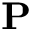<formula> <loc_0><loc_0><loc_500><loc_500>P</formula> 